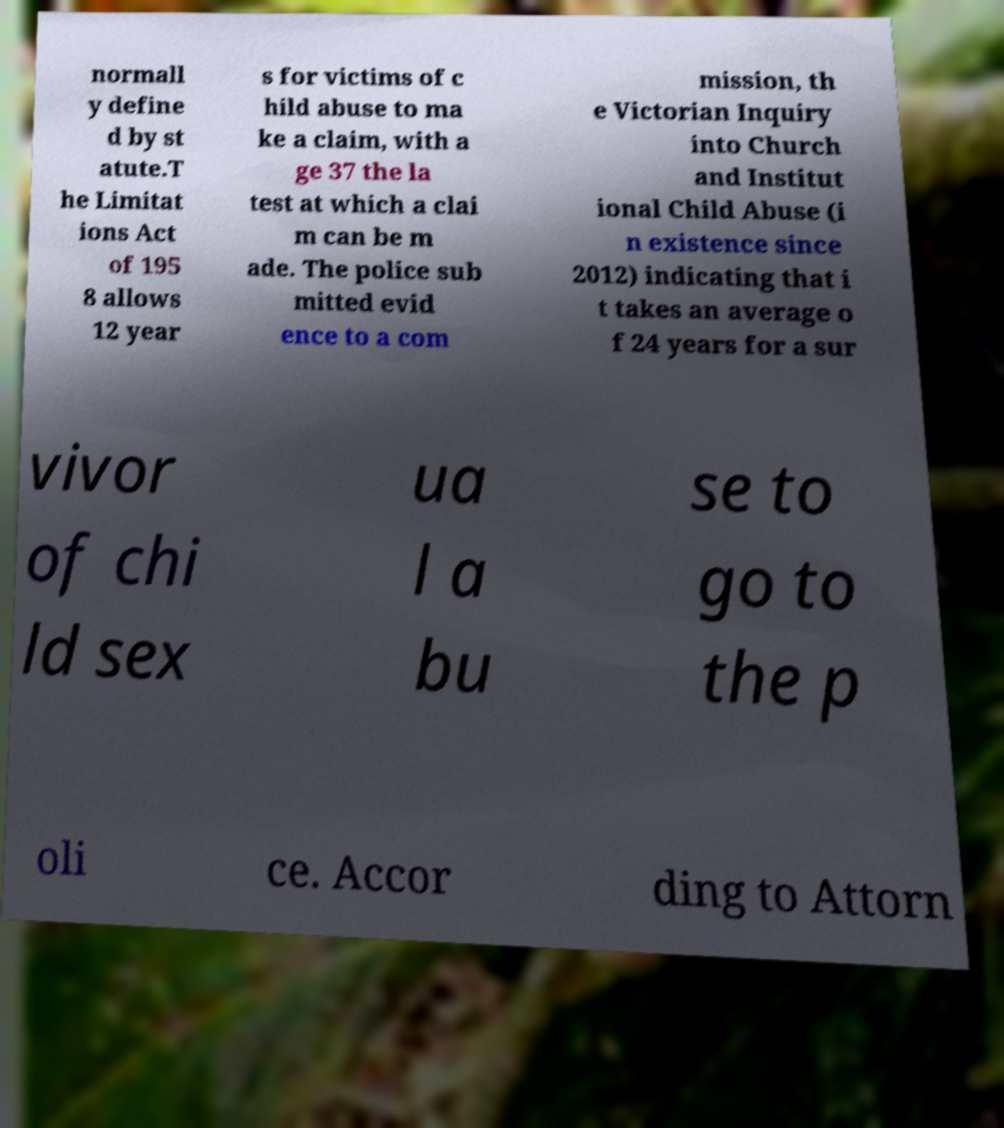Please identify and transcribe the text found in this image. normall y define d by st atute.T he Limitat ions Act of 195 8 allows 12 year s for victims of c hild abuse to ma ke a claim, with a ge 37 the la test at which a clai m can be m ade. The police sub mitted evid ence to a com mission, th e Victorian Inquiry into Church and Institut ional Child Abuse (i n existence since 2012) indicating that i t takes an average o f 24 years for a sur vivor of chi ld sex ua l a bu se to go to the p oli ce. Accor ding to Attorn 